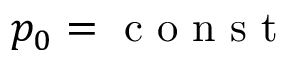<formula> <loc_0><loc_0><loc_500><loc_500>p _ { 0 } = c o n s t</formula> 